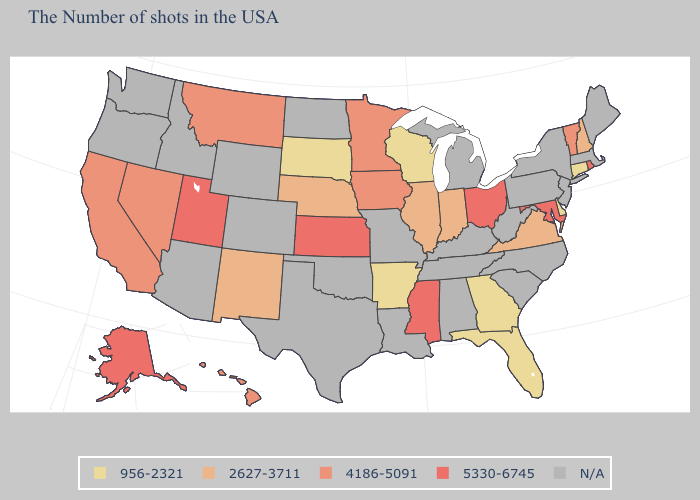What is the highest value in states that border South Carolina?
Short answer required. 956-2321. Among the states that border Mississippi , which have the lowest value?
Short answer required. Arkansas. Does Connecticut have the lowest value in the USA?
Give a very brief answer. Yes. Name the states that have a value in the range 2627-3711?
Be succinct. New Hampshire, Virginia, Indiana, Illinois, Nebraska, New Mexico. Which states hav the highest value in the MidWest?
Answer briefly. Ohio, Kansas. Name the states that have a value in the range 4186-5091?
Be succinct. Vermont, Minnesota, Iowa, Montana, Nevada, California, Hawaii. Is the legend a continuous bar?
Give a very brief answer. No. Which states hav the highest value in the Northeast?
Quick response, please. Rhode Island. Among the states that border Tennessee , which have the highest value?
Write a very short answer. Mississippi. Among the states that border Kentucky , which have the lowest value?
Answer briefly. Virginia, Indiana, Illinois. What is the value of Texas?
Quick response, please. N/A. Is the legend a continuous bar?
Concise answer only. No. What is the highest value in the USA?
Be succinct. 5330-6745. What is the lowest value in the USA?
Keep it brief. 956-2321. 